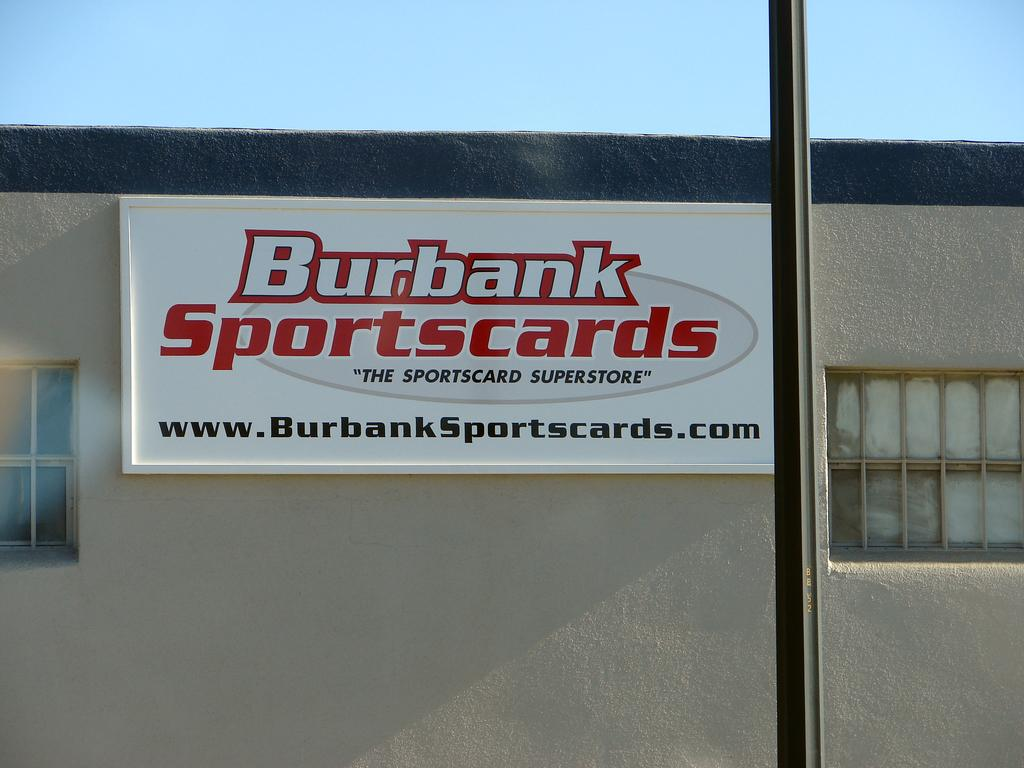What is the main object in the image? There is a name board in the image. Where is the name board located? The name board is attached to a building or a wall. What else can be seen in the image besides the name board? There is a pole in the image. What can be seen in the background of the image? The sky is visible in the background of the image. What type of vessel is being used by the sister in the image? There is no vessel or sister present in the image; it only features a name board, a pole, and the sky in the background. 